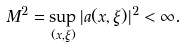<formula> <loc_0><loc_0><loc_500><loc_500>M ^ { 2 } = \sup _ { ( x , \xi ) } | a ( x , \xi ) | ^ { 2 } < \infty .</formula> 